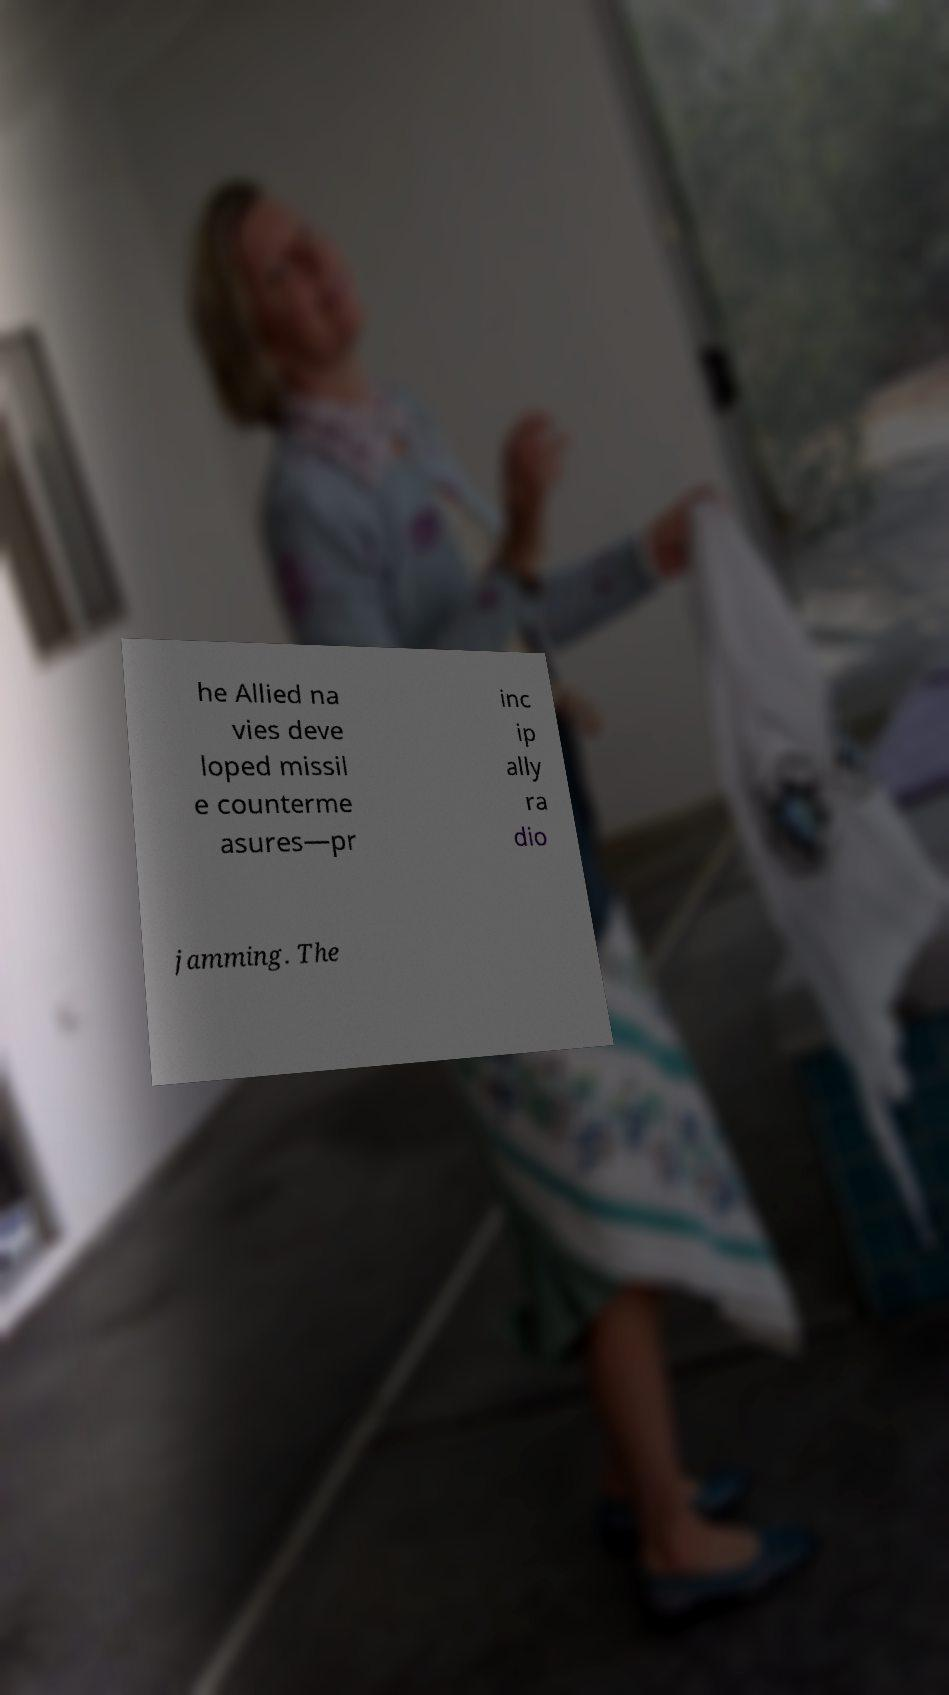Can you accurately transcribe the text from the provided image for me? he Allied na vies deve loped missil e counterme asures—pr inc ip ally ra dio jamming. The 